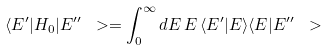Convert formula to latex. <formula><loc_0><loc_0><loc_500><loc_500>\langle E ^ { \prime } | H _ { 0 } | E ^ { \prime \prime } \ > = \int _ { 0 } ^ { \infty } d E \, E \, \langle E ^ { \prime } | E \rangle \langle E | E ^ { \prime \prime } \ ></formula> 